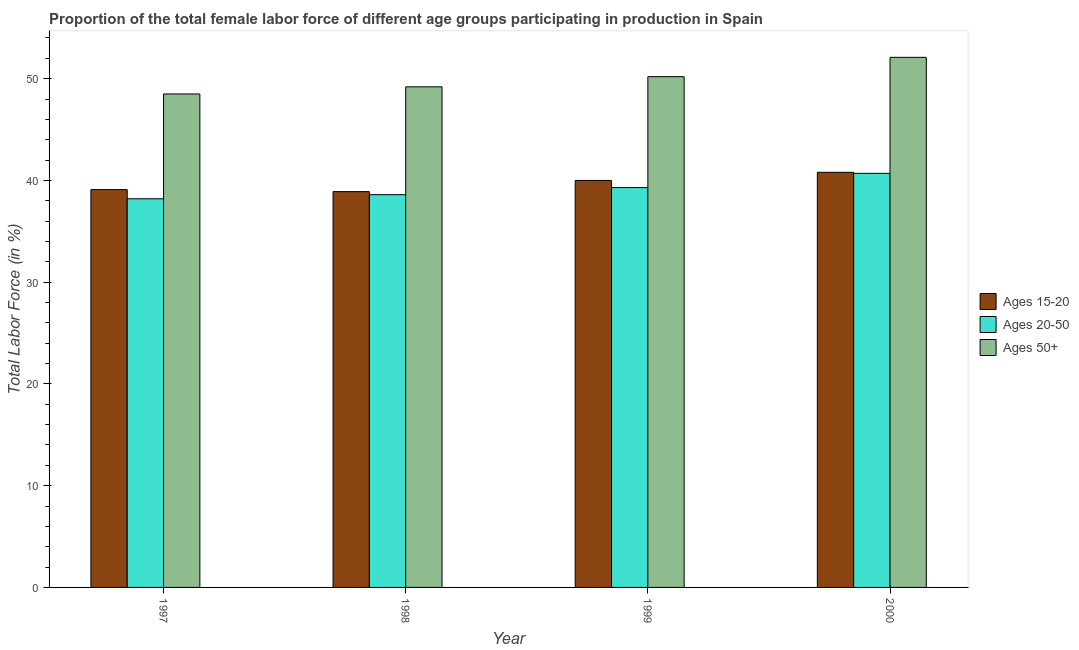How many different coloured bars are there?
Offer a very short reply. 3. Are the number of bars per tick equal to the number of legend labels?
Your response must be concise. Yes. Are the number of bars on each tick of the X-axis equal?
Keep it short and to the point. Yes. How many bars are there on the 3rd tick from the left?
Offer a very short reply. 3. What is the label of the 2nd group of bars from the left?
Your response must be concise. 1998. In how many cases, is the number of bars for a given year not equal to the number of legend labels?
Provide a short and direct response. 0. What is the percentage of female labor force within the age group 15-20 in 2000?
Offer a terse response. 40.8. Across all years, what is the maximum percentage of female labor force above age 50?
Ensure brevity in your answer.  52.1. Across all years, what is the minimum percentage of female labor force above age 50?
Give a very brief answer. 48.5. In which year was the percentage of female labor force above age 50 minimum?
Your answer should be compact. 1997. What is the total percentage of female labor force within the age group 20-50 in the graph?
Provide a short and direct response. 156.8. What is the difference between the percentage of female labor force above age 50 in 1997 and that in 1999?
Make the answer very short. -1.7. What is the difference between the percentage of female labor force within the age group 15-20 in 1999 and the percentage of female labor force above age 50 in 1998?
Ensure brevity in your answer.  1.1. What is the average percentage of female labor force within the age group 20-50 per year?
Offer a terse response. 39.2. In the year 1998, what is the difference between the percentage of female labor force within the age group 15-20 and percentage of female labor force above age 50?
Ensure brevity in your answer.  0. What is the ratio of the percentage of female labor force above age 50 in 1997 to that in 1999?
Your answer should be very brief. 0.97. Is the percentage of female labor force above age 50 in 1998 less than that in 1999?
Offer a terse response. Yes. Is the difference between the percentage of female labor force within the age group 20-50 in 1998 and 1999 greater than the difference between the percentage of female labor force within the age group 15-20 in 1998 and 1999?
Make the answer very short. No. What is the difference between the highest and the second highest percentage of female labor force above age 50?
Offer a terse response. 1.9. What is the difference between the highest and the lowest percentage of female labor force above age 50?
Your answer should be compact. 3.6. Is the sum of the percentage of female labor force within the age group 20-50 in 1998 and 1999 greater than the maximum percentage of female labor force within the age group 15-20 across all years?
Offer a terse response. Yes. What does the 2nd bar from the left in 1998 represents?
Offer a very short reply. Ages 20-50. What does the 3rd bar from the right in 1999 represents?
Offer a terse response. Ages 15-20. Is it the case that in every year, the sum of the percentage of female labor force within the age group 15-20 and percentage of female labor force within the age group 20-50 is greater than the percentage of female labor force above age 50?
Ensure brevity in your answer.  Yes. How many bars are there?
Offer a terse response. 12. Are all the bars in the graph horizontal?
Your response must be concise. No. How many years are there in the graph?
Offer a very short reply. 4. Are the values on the major ticks of Y-axis written in scientific E-notation?
Ensure brevity in your answer.  No. Where does the legend appear in the graph?
Offer a terse response. Center right. How many legend labels are there?
Ensure brevity in your answer.  3. What is the title of the graph?
Give a very brief answer. Proportion of the total female labor force of different age groups participating in production in Spain. Does "Tertiary education" appear as one of the legend labels in the graph?
Offer a terse response. No. What is the label or title of the X-axis?
Your answer should be very brief. Year. What is the label or title of the Y-axis?
Keep it short and to the point. Total Labor Force (in %). What is the Total Labor Force (in %) in Ages 15-20 in 1997?
Keep it short and to the point. 39.1. What is the Total Labor Force (in %) of Ages 20-50 in 1997?
Your answer should be very brief. 38.2. What is the Total Labor Force (in %) in Ages 50+ in 1997?
Offer a terse response. 48.5. What is the Total Labor Force (in %) of Ages 15-20 in 1998?
Provide a short and direct response. 38.9. What is the Total Labor Force (in %) of Ages 20-50 in 1998?
Offer a very short reply. 38.6. What is the Total Labor Force (in %) of Ages 50+ in 1998?
Your response must be concise. 49.2. What is the Total Labor Force (in %) of Ages 15-20 in 1999?
Make the answer very short. 40. What is the Total Labor Force (in %) of Ages 20-50 in 1999?
Make the answer very short. 39.3. What is the Total Labor Force (in %) of Ages 50+ in 1999?
Offer a very short reply. 50.2. What is the Total Labor Force (in %) in Ages 15-20 in 2000?
Offer a terse response. 40.8. What is the Total Labor Force (in %) in Ages 20-50 in 2000?
Offer a very short reply. 40.7. What is the Total Labor Force (in %) in Ages 50+ in 2000?
Keep it short and to the point. 52.1. Across all years, what is the maximum Total Labor Force (in %) of Ages 15-20?
Make the answer very short. 40.8. Across all years, what is the maximum Total Labor Force (in %) in Ages 20-50?
Offer a very short reply. 40.7. Across all years, what is the maximum Total Labor Force (in %) of Ages 50+?
Provide a short and direct response. 52.1. Across all years, what is the minimum Total Labor Force (in %) of Ages 15-20?
Offer a very short reply. 38.9. Across all years, what is the minimum Total Labor Force (in %) in Ages 20-50?
Offer a very short reply. 38.2. Across all years, what is the minimum Total Labor Force (in %) in Ages 50+?
Make the answer very short. 48.5. What is the total Total Labor Force (in %) in Ages 15-20 in the graph?
Offer a terse response. 158.8. What is the total Total Labor Force (in %) of Ages 20-50 in the graph?
Provide a succinct answer. 156.8. What is the total Total Labor Force (in %) of Ages 50+ in the graph?
Provide a succinct answer. 200. What is the difference between the Total Labor Force (in %) of Ages 15-20 in 1997 and that in 1998?
Your answer should be very brief. 0.2. What is the difference between the Total Labor Force (in %) of Ages 15-20 in 1997 and that in 2000?
Provide a short and direct response. -1.7. What is the difference between the Total Labor Force (in %) of Ages 50+ in 1997 and that in 2000?
Offer a terse response. -3.6. What is the difference between the Total Labor Force (in %) of Ages 15-20 in 1998 and that in 1999?
Give a very brief answer. -1.1. What is the difference between the Total Labor Force (in %) of Ages 20-50 in 1998 and that in 1999?
Offer a very short reply. -0.7. What is the difference between the Total Labor Force (in %) of Ages 50+ in 1998 and that in 1999?
Your response must be concise. -1. What is the difference between the Total Labor Force (in %) in Ages 50+ in 1998 and that in 2000?
Make the answer very short. -2.9. What is the difference between the Total Labor Force (in %) of Ages 50+ in 1999 and that in 2000?
Keep it short and to the point. -1.9. What is the difference between the Total Labor Force (in %) in Ages 15-20 in 1997 and the Total Labor Force (in %) in Ages 20-50 in 1998?
Your answer should be very brief. 0.5. What is the difference between the Total Labor Force (in %) of Ages 15-20 in 1997 and the Total Labor Force (in %) of Ages 50+ in 1998?
Provide a short and direct response. -10.1. What is the difference between the Total Labor Force (in %) of Ages 15-20 in 1997 and the Total Labor Force (in %) of Ages 50+ in 1999?
Your answer should be very brief. -11.1. What is the difference between the Total Labor Force (in %) of Ages 20-50 in 1997 and the Total Labor Force (in %) of Ages 50+ in 1999?
Provide a short and direct response. -12. What is the difference between the Total Labor Force (in %) of Ages 20-50 in 1998 and the Total Labor Force (in %) of Ages 50+ in 1999?
Offer a very short reply. -11.6. What is the difference between the Total Labor Force (in %) in Ages 15-20 in 1998 and the Total Labor Force (in %) in Ages 20-50 in 2000?
Provide a short and direct response. -1.8. What is the difference between the Total Labor Force (in %) in Ages 15-20 in 1998 and the Total Labor Force (in %) in Ages 50+ in 2000?
Your answer should be very brief. -13.2. What is the difference between the Total Labor Force (in %) in Ages 20-50 in 1999 and the Total Labor Force (in %) in Ages 50+ in 2000?
Offer a very short reply. -12.8. What is the average Total Labor Force (in %) of Ages 15-20 per year?
Give a very brief answer. 39.7. What is the average Total Labor Force (in %) in Ages 20-50 per year?
Offer a very short reply. 39.2. In the year 1997, what is the difference between the Total Labor Force (in %) in Ages 20-50 and Total Labor Force (in %) in Ages 50+?
Provide a short and direct response. -10.3. In the year 1998, what is the difference between the Total Labor Force (in %) of Ages 15-20 and Total Labor Force (in %) of Ages 20-50?
Your response must be concise. 0.3. In the year 1998, what is the difference between the Total Labor Force (in %) in Ages 20-50 and Total Labor Force (in %) in Ages 50+?
Provide a short and direct response. -10.6. In the year 1999, what is the difference between the Total Labor Force (in %) in Ages 15-20 and Total Labor Force (in %) in Ages 50+?
Your response must be concise. -10.2. In the year 2000, what is the difference between the Total Labor Force (in %) in Ages 15-20 and Total Labor Force (in %) in Ages 20-50?
Your answer should be very brief. 0.1. In the year 2000, what is the difference between the Total Labor Force (in %) in Ages 15-20 and Total Labor Force (in %) in Ages 50+?
Ensure brevity in your answer.  -11.3. In the year 2000, what is the difference between the Total Labor Force (in %) in Ages 20-50 and Total Labor Force (in %) in Ages 50+?
Give a very brief answer. -11.4. What is the ratio of the Total Labor Force (in %) of Ages 15-20 in 1997 to that in 1998?
Provide a succinct answer. 1.01. What is the ratio of the Total Labor Force (in %) in Ages 50+ in 1997 to that in 1998?
Provide a short and direct response. 0.99. What is the ratio of the Total Labor Force (in %) in Ages 15-20 in 1997 to that in 1999?
Make the answer very short. 0.98. What is the ratio of the Total Labor Force (in %) in Ages 20-50 in 1997 to that in 1999?
Offer a very short reply. 0.97. What is the ratio of the Total Labor Force (in %) in Ages 50+ in 1997 to that in 1999?
Provide a short and direct response. 0.97. What is the ratio of the Total Labor Force (in %) in Ages 20-50 in 1997 to that in 2000?
Your answer should be very brief. 0.94. What is the ratio of the Total Labor Force (in %) of Ages 50+ in 1997 to that in 2000?
Make the answer very short. 0.93. What is the ratio of the Total Labor Force (in %) in Ages 15-20 in 1998 to that in 1999?
Your answer should be compact. 0.97. What is the ratio of the Total Labor Force (in %) of Ages 20-50 in 1998 to that in 1999?
Provide a succinct answer. 0.98. What is the ratio of the Total Labor Force (in %) of Ages 50+ in 1998 to that in 1999?
Ensure brevity in your answer.  0.98. What is the ratio of the Total Labor Force (in %) in Ages 15-20 in 1998 to that in 2000?
Ensure brevity in your answer.  0.95. What is the ratio of the Total Labor Force (in %) in Ages 20-50 in 1998 to that in 2000?
Offer a terse response. 0.95. What is the ratio of the Total Labor Force (in %) of Ages 50+ in 1998 to that in 2000?
Offer a very short reply. 0.94. What is the ratio of the Total Labor Force (in %) in Ages 15-20 in 1999 to that in 2000?
Make the answer very short. 0.98. What is the ratio of the Total Labor Force (in %) of Ages 20-50 in 1999 to that in 2000?
Ensure brevity in your answer.  0.97. What is the ratio of the Total Labor Force (in %) of Ages 50+ in 1999 to that in 2000?
Offer a terse response. 0.96. What is the difference between the highest and the second highest Total Labor Force (in %) of Ages 20-50?
Keep it short and to the point. 1.4. What is the difference between the highest and the lowest Total Labor Force (in %) in Ages 15-20?
Your answer should be compact. 1.9. What is the difference between the highest and the lowest Total Labor Force (in %) in Ages 20-50?
Offer a very short reply. 2.5. 